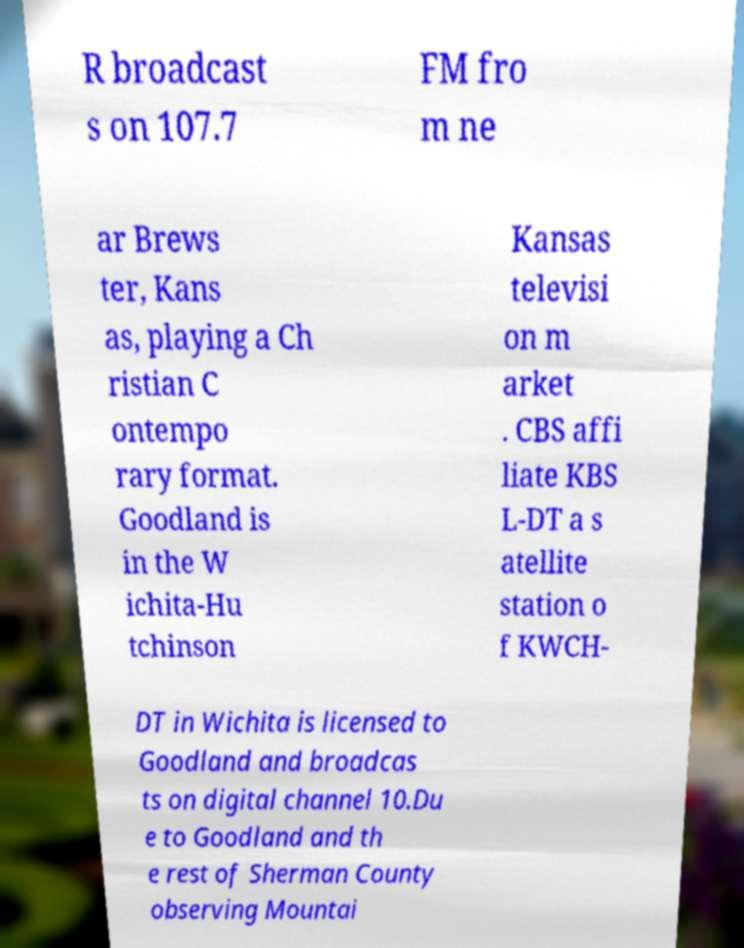I need the written content from this picture converted into text. Can you do that? R broadcast s on 107.7 FM fro m ne ar Brews ter, Kans as, playing a Ch ristian C ontempo rary format. Goodland is in the W ichita-Hu tchinson Kansas televisi on m arket . CBS affi liate KBS L-DT a s atellite station o f KWCH- DT in Wichita is licensed to Goodland and broadcas ts on digital channel 10.Du e to Goodland and th e rest of Sherman County observing Mountai 